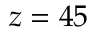Convert formula to latex. <formula><loc_0><loc_0><loc_500><loc_500>z = 4 5</formula> 